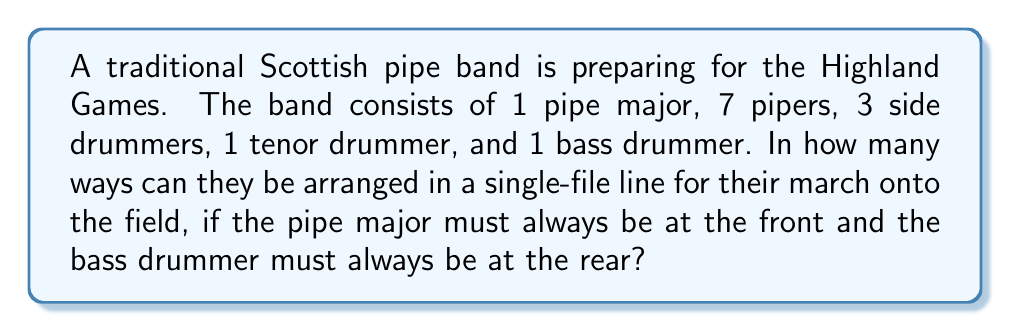What is the answer to this math problem? Let's approach this step-by-step:

1) First, we need to recognize that the positions of the pipe major and the bass drummer are fixed. The pipe major is always at the front, and the bass drummer is always at the rear. This leaves 11 positions to be filled by the remaining 11 musicians.

2) We now have to arrange 7 pipers, 3 side drummers, and 1 tenor drummer in these 11 positions.

3) This is a permutation problem. We're arranging 11 distinct positions, but some of the musicians (the pipers and side drummers) are indistinguishable from each other.

4) The formula for this type of permutation is:

   $$\frac{11!}{7!3!1!}$$

   Where 11! represents the total number of ways to arrange 11 distinct items, and we divide by 7!, 3!, and 1! to account for the indistinguishable pipers, side drummers, and tenor drummer respectively.

5) Let's calculate this:

   $$\frac{11!}{7!3!1!} = \frac{11 \times 10 \times 9 \times 8 \times 7!}{7! \times 3 \times 2 \times 1 \times 1}$$

6) The 7! cancels out in the numerator and denominator:

   $$= \frac{11 \times 10 \times 9 \times 8}{3 \times 2 \times 1} = \frac{7920}{6} = 1320$$

Therefore, there are 1320 possible ways to arrange the band members.
Answer: 1320 possible arrangements 